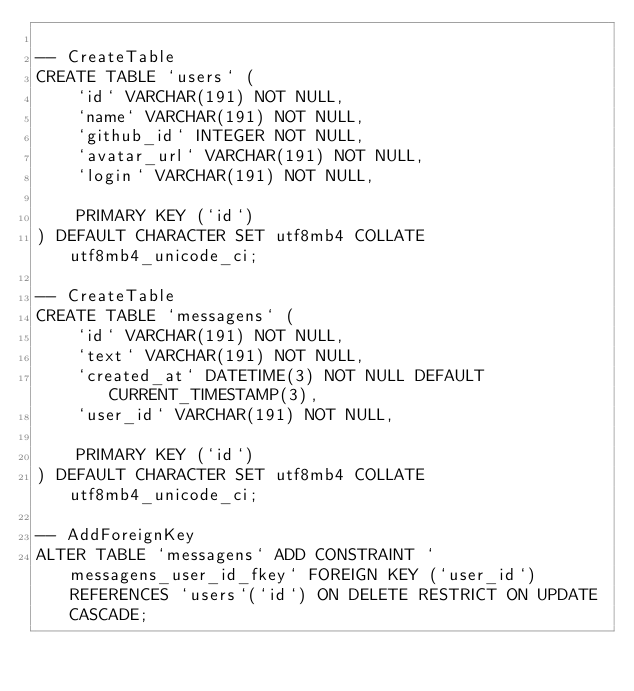<code> <loc_0><loc_0><loc_500><loc_500><_SQL_>
-- CreateTable
CREATE TABLE `users` (
    `id` VARCHAR(191) NOT NULL,
    `name` VARCHAR(191) NOT NULL,
    `github_id` INTEGER NOT NULL,
    `avatar_url` VARCHAR(191) NOT NULL,
    `login` VARCHAR(191) NOT NULL,

    PRIMARY KEY (`id`)
) DEFAULT CHARACTER SET utf8mb4 COLLATE utf8mb4_unicode_ci;

-- CreateTable
CREATE TABLE `messagens` (
    `id` VARCHAR(191) NOT NULL,
    `text` VARCHAR(191) NOT NULL,
    `created_at` DATETIME(3) NOT NULL DEFAULT CURRENT_TIMESTAMP(3),
    `user_id` VARCHAR(191) NOT NULL,

    PRIMARY KEY (`id`)
) DEFAULT CHARACTER SET utf8mb4 COLLATE utf8mb4_unicode_ci;

-- AddForeignKey
ALTER TABLE `messagens` ADD CONSTRAINT `messagens_user_id_fkey` FOREIGN KEY (`user_id`) REFERENCES `users`(`id`) ON DELETE RESTRICT ON UPDATE CASCADE;
</code> 